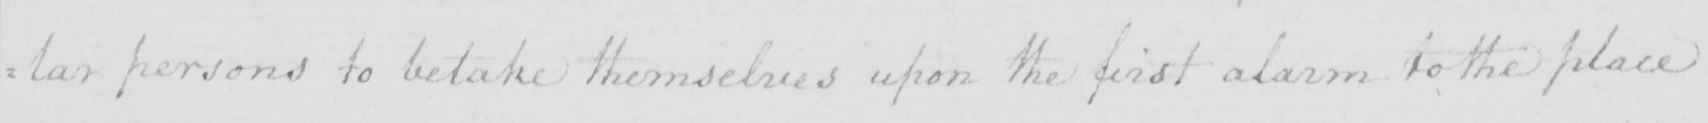Can you tell me what this handwritten text says? : lar persons to betake themselves upon the first alarm to the place 